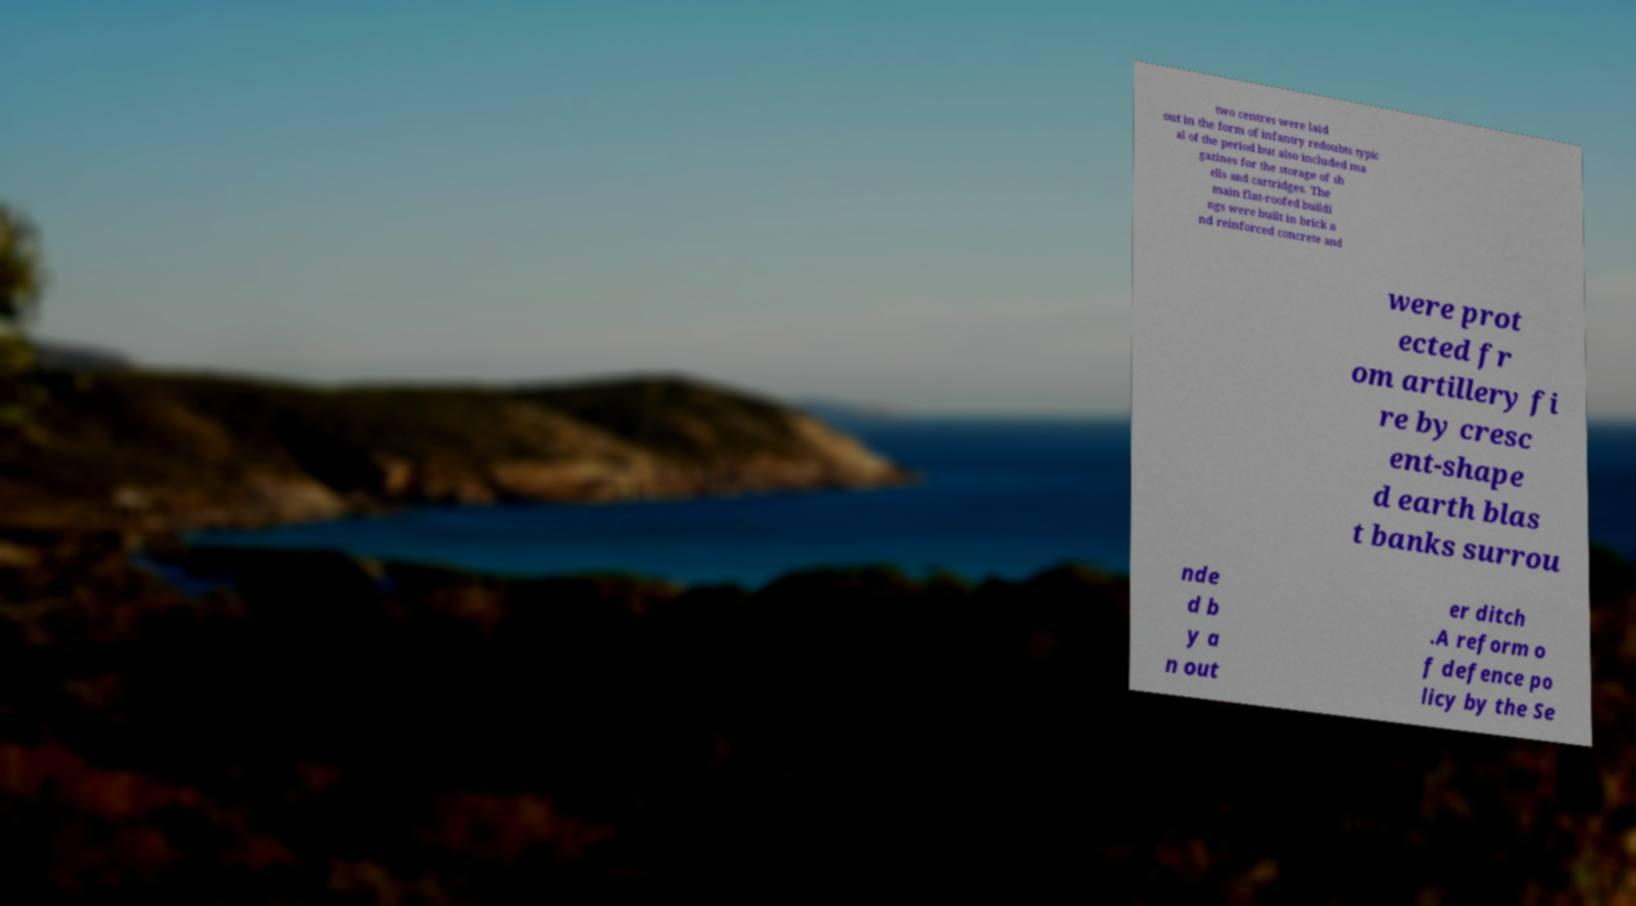There's text embedded in this image that I need extracted. Can you transcribe it verbatim? two centres were laid out in the form of infantry redoubts typic al of the period but also included ma gazines for the storage of sh ells and cartridges. The main flat-roofed buildi ngs were built in brick a nd reinforced concrete and were prot ected fr om artillery fi re by cresc ent-shape d earth blas t banks surrou nde d b y a n out er ditch .A reform o f defence po licy by the Se 